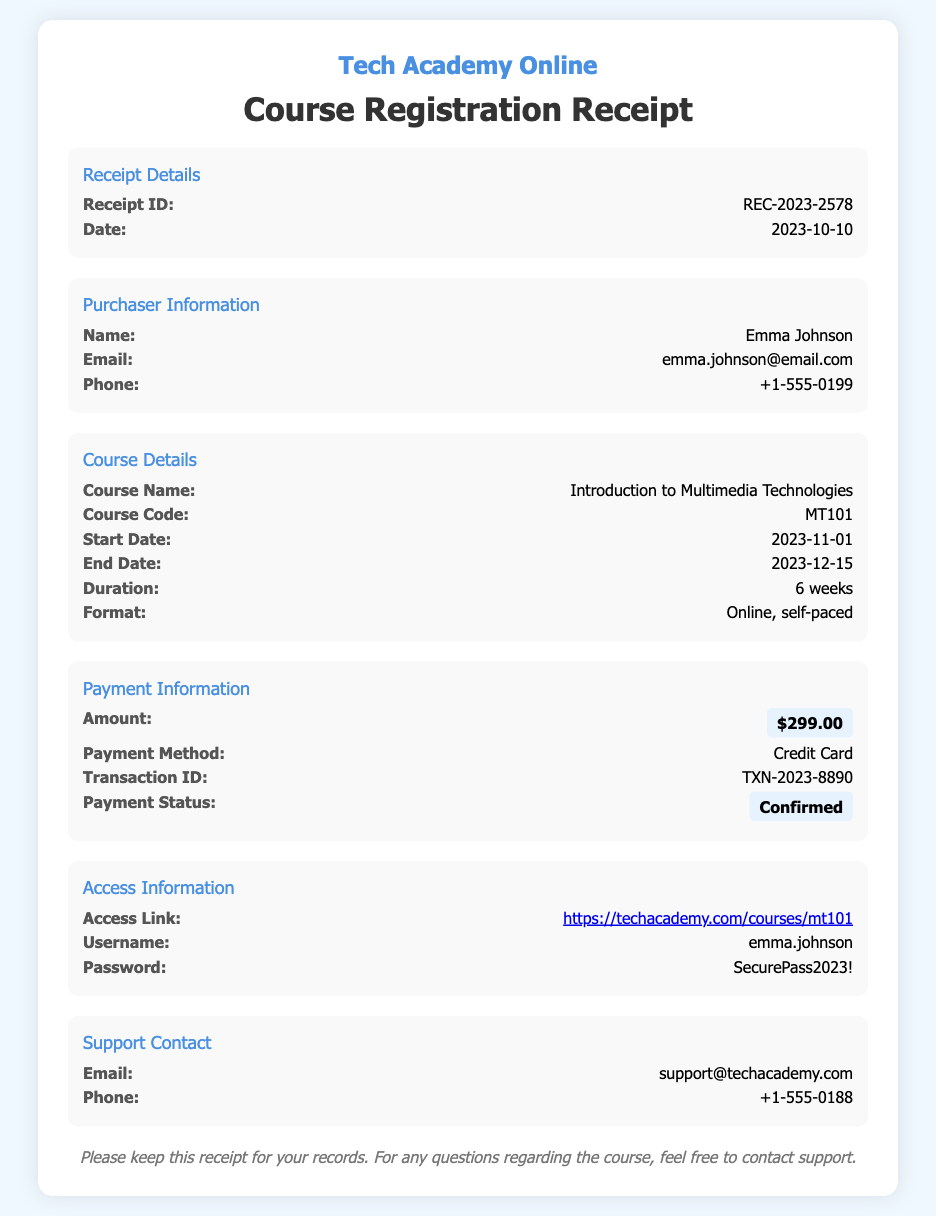what is the course name? The course name is explicitly mentioned in the document under Course Details.
Answer: Introduction to Multimedia Technologies what is the receipt ID? The receipt ID is specified at the beginning of the Receipt Details section.
Answer: REC-2023-2578 what is the payment amount? The payment amount is highlighted in the Payment Information section.
Answer: $299.00 what is the course duration? The duration of the course is outlined in the Course Details section.
Answer: 6 weeks what is the start date of the course? The start date can be found in the Course Details section of the document.
Answer: 2023-11-01 who is the purchaser? The purchaser's name is listed in the Purchaser Information section.
Answer: Emma Johnson what is the transaction ID? The transaction ID is recorded in the Payment Information section.
Answer: TXN-2023-8890 what is the username for course access? The username is found in the Access Information section.
Answer: emma.johnson what is the payment status? The payment status is highlighted in the Payment Information section.
Answer: Confirmed what is the support email? The support email is noted in the Support Contact section.
Answer: support@techacademy.com 